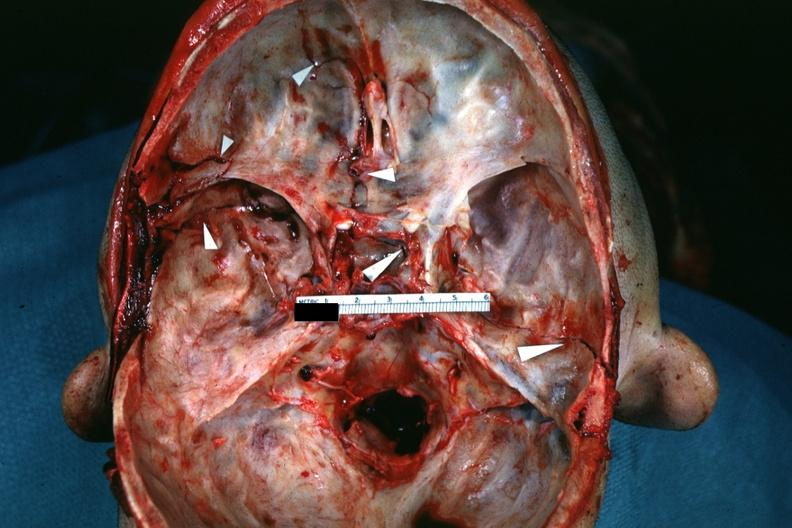what is present?
Answer the question using a single word or phrase. Bone, calvarium 